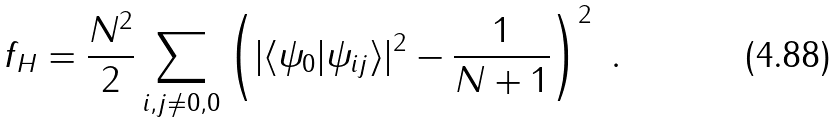<formula> <loc_0><loc_0><loc_500><loc_500>f _ { H } = \frac { N ^ { 2 } } { 2 } \sum _ { i , j \neq 0 , 0 } \left ( | \langle \psi _ { 0 } | \psi _ { i j } \rangle | ^ { 2 } - \frac { 1 } { N + 1 } \right ) ^ { 2 } \ .</formula> 